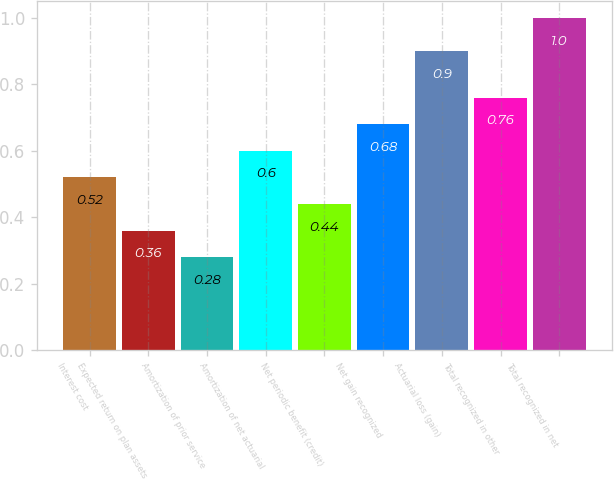Convert chart. <chart><loc_0><loc_0><loc_500><loc_500><bar_chart><fcel>Interest cost<fcel>Expected return on plan assets<fcel>Amortization of prior service<fcel>Amortization of net actuarial<fcel>Net periodic benefit (credit)<fcel>Net gain recognized<fcel>Actuarial loss (gain)<fcel>Total recognized in other<fcel>Total recognized in net<nl><fcel>0.52<fcel>0.36<fcel>0.28<fcel>0.6<fcel>0.44<fcel>0.68<fcel>0.9<fcel>0.76<fcel>1<nl></chart> 